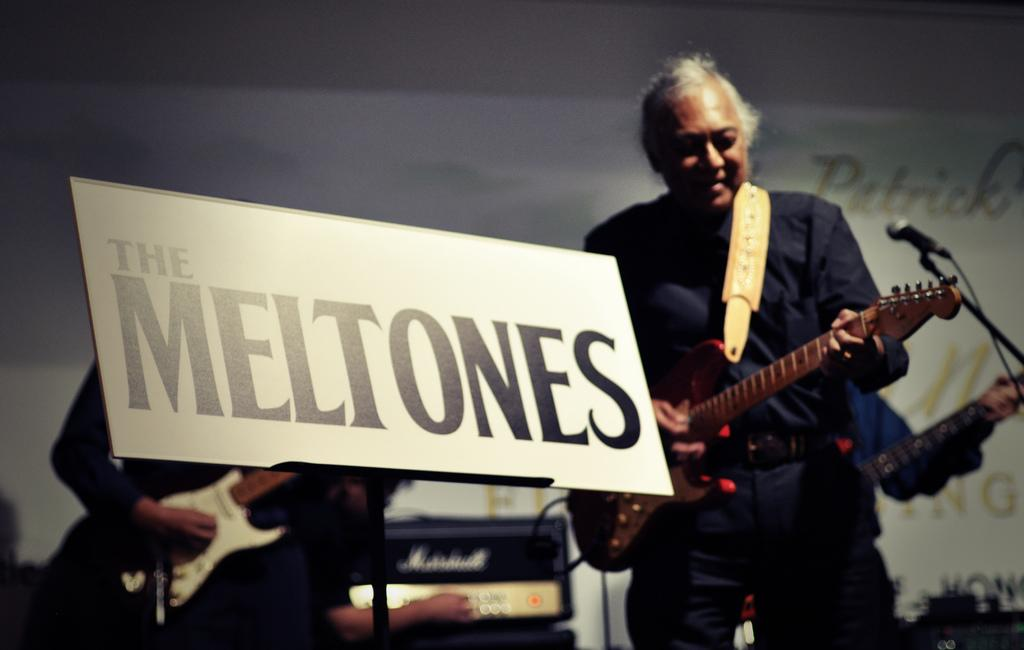What are the two persons in the image doing? The two persons in the image are holding guitars. What can be seen written on the board in the image? The board reads "The Mel tones". What object is present for amplifying sound in the image? There is a microphone ine in the image. What additional signage is visible in the image? There is a banner visible in the image. Can you tell me how many brothers are playing the guitar in the image? There is no information about brothers in the image; it only shows two persons holding guitars. 